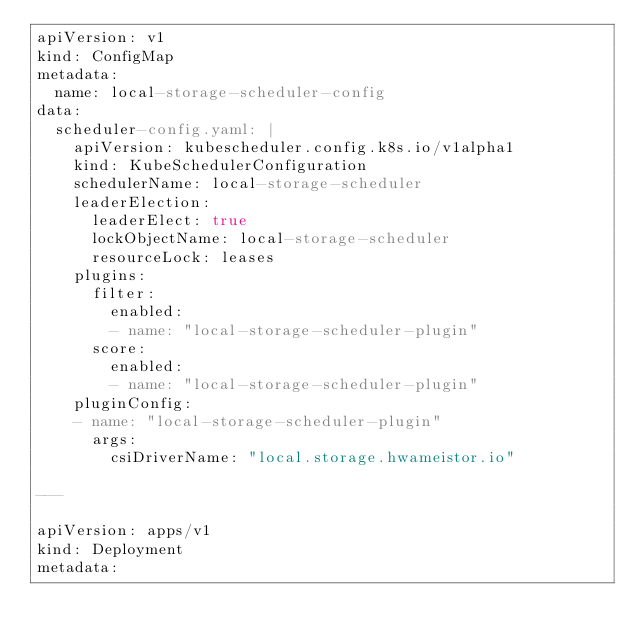<code> <loc_0><loc_0><loc_500><loc_500><_YAML_>apiVersion: v1
kind: ConfigMap
metadata:
  name: local-storage-scheduler-config
data:
  scheduler-config.yaml: |
    apiVersion: kubescheduler.config.k8s.io/v1alpha1
    kind: KubeSchedulerConfiguration
    schedulerName: local-storage-scheduler
    leaderElection:
      leaderElect: true
      lockObjectName: local-storage-scheduler
      resourceLock: leases
    plugins:
      filter:
        enabled:
        - name: "local-storage-scheduler-plugin"
      score:
        enabled:
        - name: "local-storage-scheduler-plugin"
    pluginConfig:
    - name: "local-storage-scheduler-plugin"
      args:
        csiDriverName: "local.storage.hwameistor.io"

---

apiVersion: apps/v1
kind: Deployment
metadata:</code> 